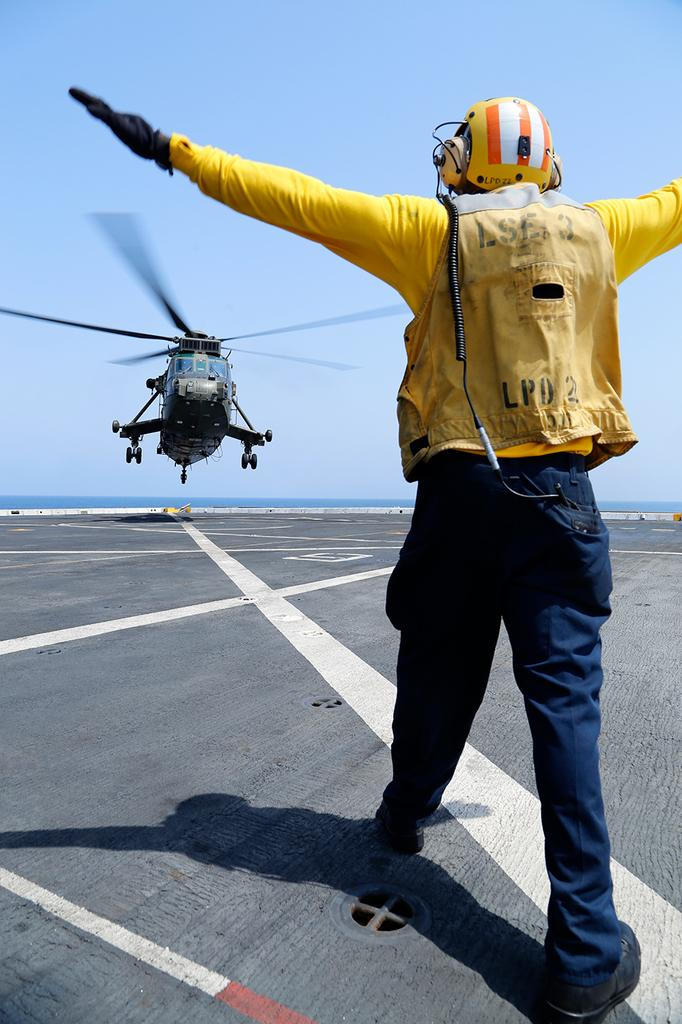What is the man in the image doing? The man is standing on the runway. What protective gear is the man wearing? The man is wearing a helmet and headphones. What can be seen flying in the sky in the image? There is a helicopter flying in the sky. How would you describe the weather based on the image? The sky is clear in the image. Who is the owner of the wrist in the image? There is no wrist or any indication of ownership in the image. 